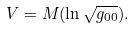Convert formula to latex. <formula><loc_0><loc_0><loc_500><loc_500>V = M ( \ln \sqrt { g _ { 0 0 } } ) .</formula> 